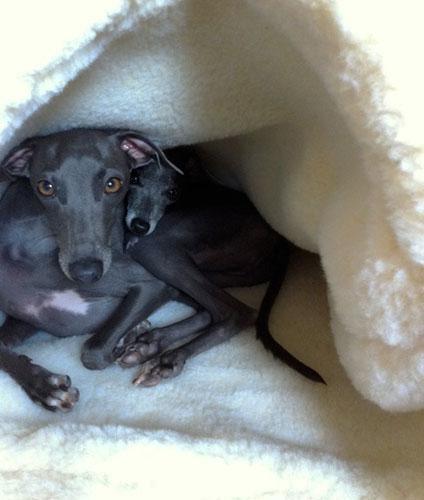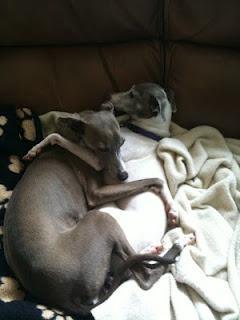The first image is the image on the left, the second image is the image on the right. Given the left and right images, does the statement "There is three dogs." hold true? Answer yes or no. Yes. The first image is the image on the left, the second image is the image on the right. For the images displayed, is the sentence "One image shows one brown dog reclining, and the other image features a hound wearing a collar." factually correct? Answer yes or no. No. 